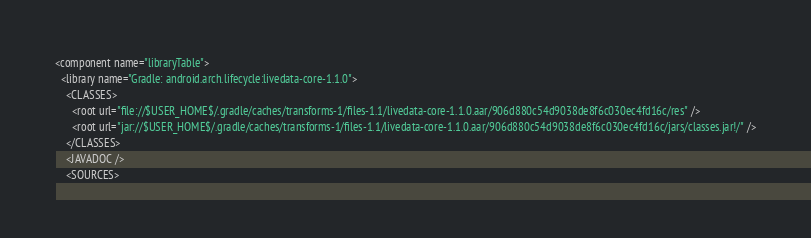<code> <loc_0><loc_0><loc_500><loc_500><_XML_><component name="libraryTable">
  <library name="Gradle: android.arch.lifecycle:livedata-core-1.1.0">
    <CLASSES>
      <root url="file://$USER_HOME$/.gradle/caches/transforms-1/files-1.1/livedata-core-1.1.0.aar/906d880c54d9038de8f6c030ec4fd16c/res" />
      <root url="jar://$USER_HOME$/.gradle/caches/transforms-1/files-1.1/livedata-core-1.1.0.aar/906d880c54d9038de8f6c030ec4fd16c/jars/classes.jar!/" />
    </CLASSES>
    <JAVADOC />
    <SOURCES></code> 